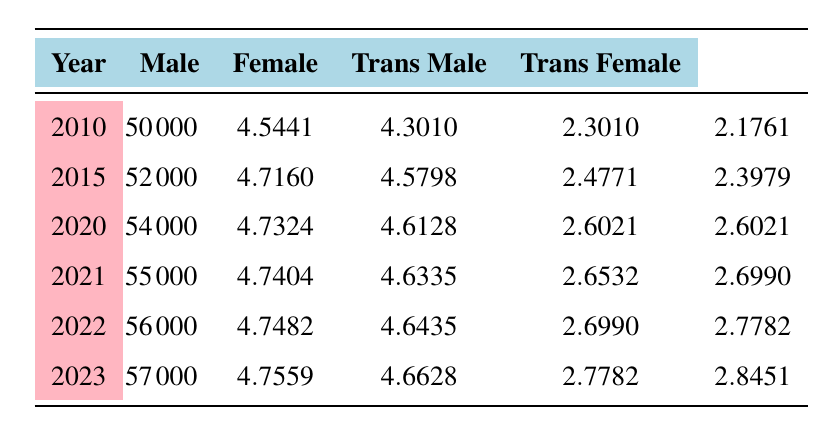What was the male participation rate in 2023? The table shows the value for male participation in 2023, which is listed under the "Male" column for the year 2023. Looking at the table, the male participation rate for 2023 is 57000.
Answer: 57000 What is the logarithmic value of female participants in 2010? From the table, the logarithmic value corresponding to female participants for the year 2010 is shown in the "Female" column. It indicates the value, which is 4.5441.
Answer: 4.5441 How many more transgender female participants were there in 2023 than in 2010? The number of transgender female participants in 2023 is 700 and in 2010 is 150. To find the difference, subtract the 2010 value from the 2023 value: 700 - 150 = 550.
Answer: 550 Is the male participation rate increasing each year? By examining the "Male" column over the years listed, we can see that the values consistently increase from 50000 in 2010 to 57000 in 2023. This indicates that male participation is indeed increasing each year.
Answer: Yes What is the average number of transgender male participants from 2010 to 2023? To find the average, sum the transgender male participants across the years: 200 + 300 + 400 + 450 + 500 + 600 = 2450. Then divide by the number of years (6): 2450 / 6 = 408.33. The average is approximately 408.33.
Answer: 408.33 What was the highest number of female participants recorded in the table? By looking at the "Female" column, we can see the participants for each year: 35000, 38000, 41000, 43000, 44000, and 46000. The highest value is 46000 in 2023.
Answer: 46000 By how much did the transgender male participation increase from 2015 to 2021? In 2015, the number of transgender male participants was 300, and in 2021 it was 450. The increase is found by subtracting the 2015 value from the 2021 value: 450 - 300 = 150.
Answer: 150 Was there ever a year where the number of transgender female participants was higher than transgender male participants? By checking each year, we see that the number of transgender female participants exceeded that of transgender male participants from 2021 onward. In 2021, there were 500 transgender females and 450 transgender males. Therefore, from 2021 onward, this is true.
Answer: Yes What was the total participation (male, female, transgender male, and transgender female) in 2022? To compute this, we find the sum of all participants in 2022: 56000 + 44000 + 500 + 600. This totals 56000 + 44000 = 100000, then adding 500 + 600 gives 100000 + 1100 = 101100.
Answer: 101100 